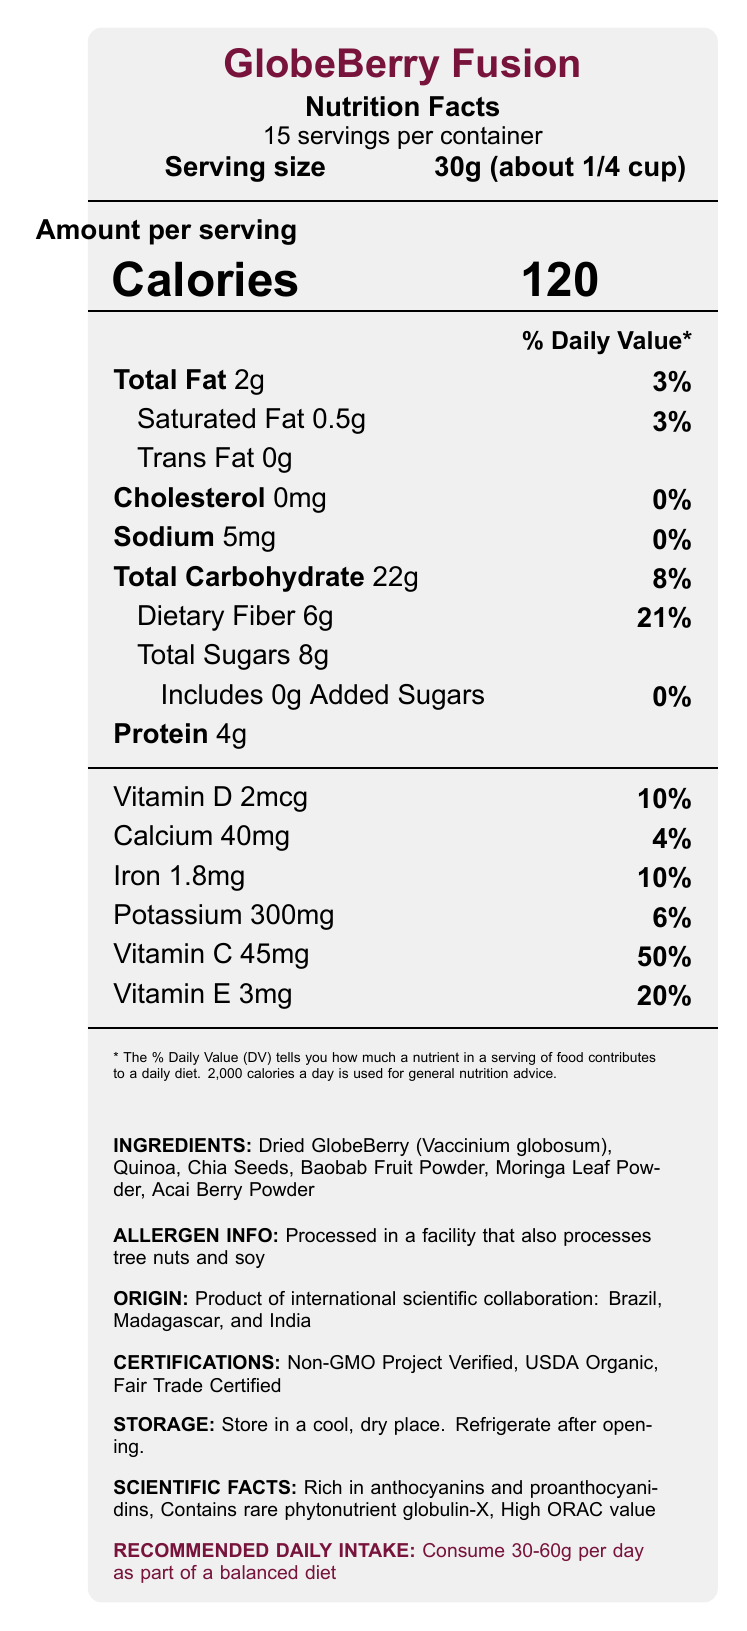what is the serving size of GlobeBerry Fusion? The document states that the serving size is 30g, which is approximately equivalent to 1/4 cup.
Answer: 30g (about 1/4 cup) how many calories are there per serving? The document lists the calories per serving as 120.
Answer: 120 what is the total carbohydrate content per serving? The document indicates that the total carbohydrate content per serving is 22g.
Answer: 22g mention three ingredients in GlobeBerry Fusion. The ingredients list includes Dried GlobeBerry (Vaccinium globosum), Quinoa, and Chia Seeds.
Answer: Dried GlobeBerry (Vaccinium globosum), Quinoa, Chia Seeds how much dietary fiber does one serving contain? The document specifies that one serving contains 6g of dietary fiber.
Answer: 6g what are the % Daily Values of Vitamin C and Vitamin E? The document shows that Vitamin C has a % DV of 50% and Vitamin E has a % DV of 20%.
Answer: Vitamin C: 50%, Vitamin E: 20% how much omega-3 fatty acids are present in one serving? The document lists omega-3 fatty acids content as 1.5g per serving.
Answer: 1.5g what certifications does GlobeBerry Fusion have? A. USDA Organic B. Fair Trade Certified C. Non-GMO Project Verified D. All of the above The document states that GlobeBerry Fusion is USDA Organic, Fair Trade Certified, and Non-GMO Project Verified.
Answer: D. All of the above which continent is not mentioned as part of the international scientific collaboration for making GlobeBerry Fusion? A. South America B. Asia C. Europe D. Africa The document mentions Brazil (South America), Madagascar (Africa), and India (Asia), but not Europe.
Answer: C. Europe are there any added sugars in GlobeBerry Fusion? The document lists added sugars as 0g, indicating that there are no added sugars.
Answer: No is GlobeBerry Fusion processed in a nut-free facility? The document mentions that it is processed in a facility that also processes tree nuts and soy.
Answer: No describe the cultural and scientific significance of GlobeBerry Fusion. The summary of the document highlights the cultural blend of superfoods across different continents, scientific richness in nutrients, collaborative origin, and sustainable packaging.
Answer: GlobeBerry Fusion combines traditional superfoods from multiple continents and is a product of international scientific collaboration involving Brazil, Madagascar, and India. It is rich in unique phytonutrients such as anthocyanins, proanthocyanidins, and globulin-X, and has a high ORAC value. The packaging is made from 100% recycled materials, making it environmentally sustainable. what is the manufacturing date of GlobeBerry Fusion? The document does not provide information regarding the manufacturing date.
Answer: Not enough information what is the recommended daily intake for GlobeBerry Fusion? The document advises consuming 30-60g per day as part of a balanced diet.
Answer: 30-60g how many grams of protein are there in one serving? The document lists the protein content as 4g per serving.
Answer: 4g is there any information about the gluten content in GlobeBerry Fusion? The document does not provide any details regarding the gluten content.
Answer: No 